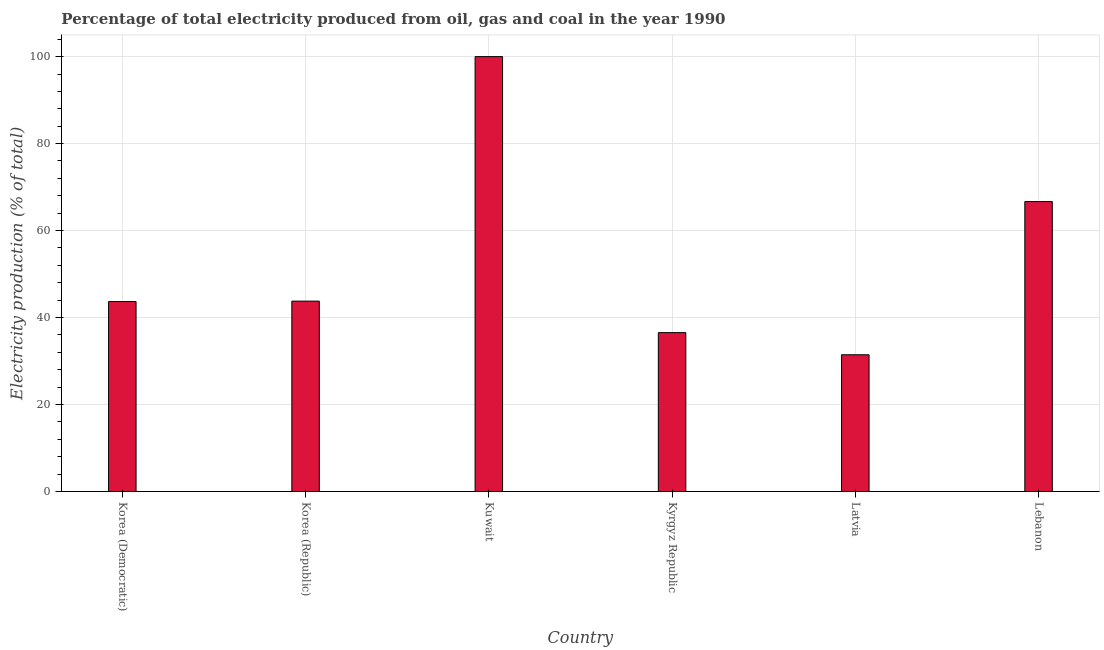Does the graph contain any zero values?
Provide a succinct answer. No. What is the title of the graph?
Give a very brief answer. Percentage of total electricity produced from oil, gas and coal in the year 1990. What is the label or title of the Y-axis?
Offer a very short reply. Electricity production (% of total). What is the electricity production in Korea (Democratic)?
Your response must be concise. 43.68. Across all countries, what is the maximum electricity production?
Give a very brief answer. 100. Across all countries, what is the minimum electricity production?
Your answer should be compact. 31.44. In which country was the electricity production maximum?
Your answer should be very brief. Kuwait. In which country was the electricity production minimum?
Your answer should be compact. Latvia. What is the sum of the electricity production?
Keep it short and to the point. 322.08. What is the difference between the electricity production in Korea (Democratic) and Kuwait?
Provide a short and direct response. -56.32. What is the average electricity production per country?
Give a very brief answer. 53.68. What is the median electricity production?
Your answer should be very brief. 43.73. In how many countries, is the electricity production greater than 76 %?
Offer a very short reply. 1. What is the ratio of the electricity production in Korea (Republic) to that in Kyrgyz Republic?
Provide a succinct answer. 1.2. Is the difference between the electricity production in Korea (Republic) and Kuwait greater than the difference between any two countries?
Give a very brief answer. No. What is the difference between the highest and the second highest electricity production?
Keep it short and to the point. 33.33. Is the sum of the electricity production in Korea (Republic) and Kyrgyz Republic greater than the maximum electricity production across all countries?
Provide a succinct answer. No. What is the difference between the highest and the lowest electricity production?
Provide a succinct answer. 68.56. What is the difference between two consecutive major ticks on the Y-axis?
Make the answer very short. 20. Are the values on the major ticks of Y-axis written in scientific E-notation?
Ensure brevity in your answer.  No. What is the Electricity production (% of total) of Korea (Democratic)?
Provide a short and direct response. 43.68. What is the Electricity production (% of total) in Korea (Republic)?
Your answer should be very brief. 43.77. What is the Electricity production (% of total) of Kuwait?
Give a very brief answer. 100. What is the Electricity production (% of total) in Kyrgyz Republic?
Your answer should be compact. 36.52. What is the Electricity production (% of total) in Latvia?
Give a very brief answer. 31.44. What is the Electricity production (% of total) in Lebanon?
Offer a terse response. 66.67. What is the difference between the Electricity production (% of total) in Korea (Democratic) and Korea (Republic)?
Provide a short and direct response. -0.09. What is the difference between the Electricity production (% of total) in Korea (Democratic) and Kuwait?
Give a very brief answer. -56.32. What is the difference between the Electricity production (% of total) in Korea (Democratic) and Kyrgyz Republic?
Your response must be concise. 7.16. What is the difference between the Electricity production (% of total) in Korea (Democratic) and Latvia?
Make the answer very short. 12.24. What is the difference between the Electricity production (% of total) in Korea (Democratic) and Lebanon?
Your response must be concise. -22.98. What is the difference between the Electricity production (% of total) in Korea (Republic) and Kuwait?
Offer a terse response. -56.23. What is the difference between the Electricity production (% of total) in Korea (Republic) and Kyrgyz Republic?
Provide a succinct answer. 7.25. What is the difference between the Electricity production (% of total) in Korea (Republic) and Latvia?
Provide a short and direct response. 12.33. What is the difference between the Electricity production (% of total) in Korea (Republic) and Lebanon?
Your response must be concise. -22.9. What is the difference between the Electricity production (% of total) in Kuwait and Kyrgyz Republic?
Your answer should be very brief. 63.48. What is the difference between the Electricity production (% of total) in Kuwait and Latvia?
Make the answer very short. 68.56. What is the difference between the Electricity production (% of total) in Kuwait and Lebanon?
Provide a short and direct response. 33.33. What is the difference between the Electricity production (% of total) in Kyrgyz Republic and Latvia?
Provide a short and direct response. 5.09. What is the difference between the Electricity production (% of total) in Kyrgyz Republic and Lebanon?
Make the answer very short. -30.14. What is the difference between the Electricity production (% of total) in Latvia and Lebanon?
Your answer should be very brief. -35.23. What is the ratio of the Electricity production (% of total) in Korea (Democratic) to that in Kuwait?
Ensure brevity in your answer.  0.44. What is the ratio of the Electricity production (% of total) in Korea (Democratic) to that in Kyrgyz Republic?
Your answer should be very brief. 1.2. What is the ratio of the Electricity production (% of total) in Korea (Democratic) to that in Latvia?
Offer a very short reply. 1.39. What is the ratio of the Electricity production (% of total) in Korea (Democratic) to that in Lebanon?
Give a very brief answer. 0.66. What is the ratio of the Electricity production (% of total) in Korea (Republic) to that in Kuwait?
Provide a short and direct response. 0.44. What is the ratio of the Electricity production (% of total) in Korea (Republic) to that in Kyrgyz Republic?
Your answer should be compact. 1.2. What is the ratio of the Electricity production (% of total) in Korea (Republic) to that in Latvia?
Keep it short and to the point. 1.39. What is the ratio of the Electricity production (% of total) in Korea (Republic) to that in Lebanon?
Give a very brief answer. 0.66. What is the ratio of the Electricity production (% of total) in Kuwait to that in Kyrgyz Republic?
Your answer should be very brief. 2.74. What is the ratio of the Electricity production (% of total) in Kuwait to that in Latvia?
Offer a terse response. 3.18. What is the ratio of the Electricity production (% of total) in Kuwait to that in Lebanon?
Your response must be concise. 1.5. What is the ratio of the Electricity production (% of total) in Kyrgyz Republic to that in Latvia?
Your answer should be very brief. 1.16. What is the ratio of the Electricity production (% of total) in Kyrgyz Republic to that in Lebanon?
Offer a terse response. 0.55. What is the ratio of the Electricity production (% of total) in Latvia to that in Lebanon?
Your response must be concise. 0.47. 